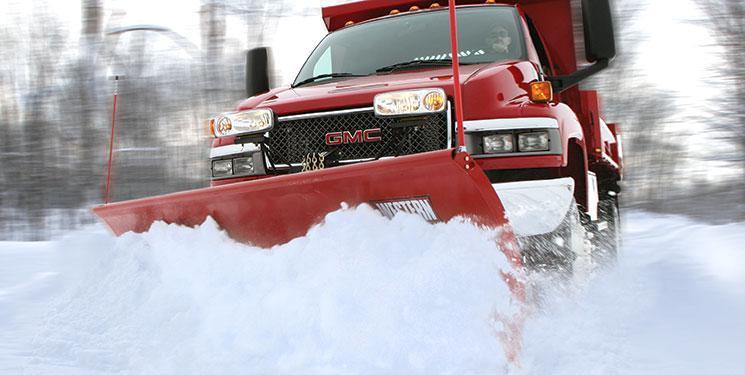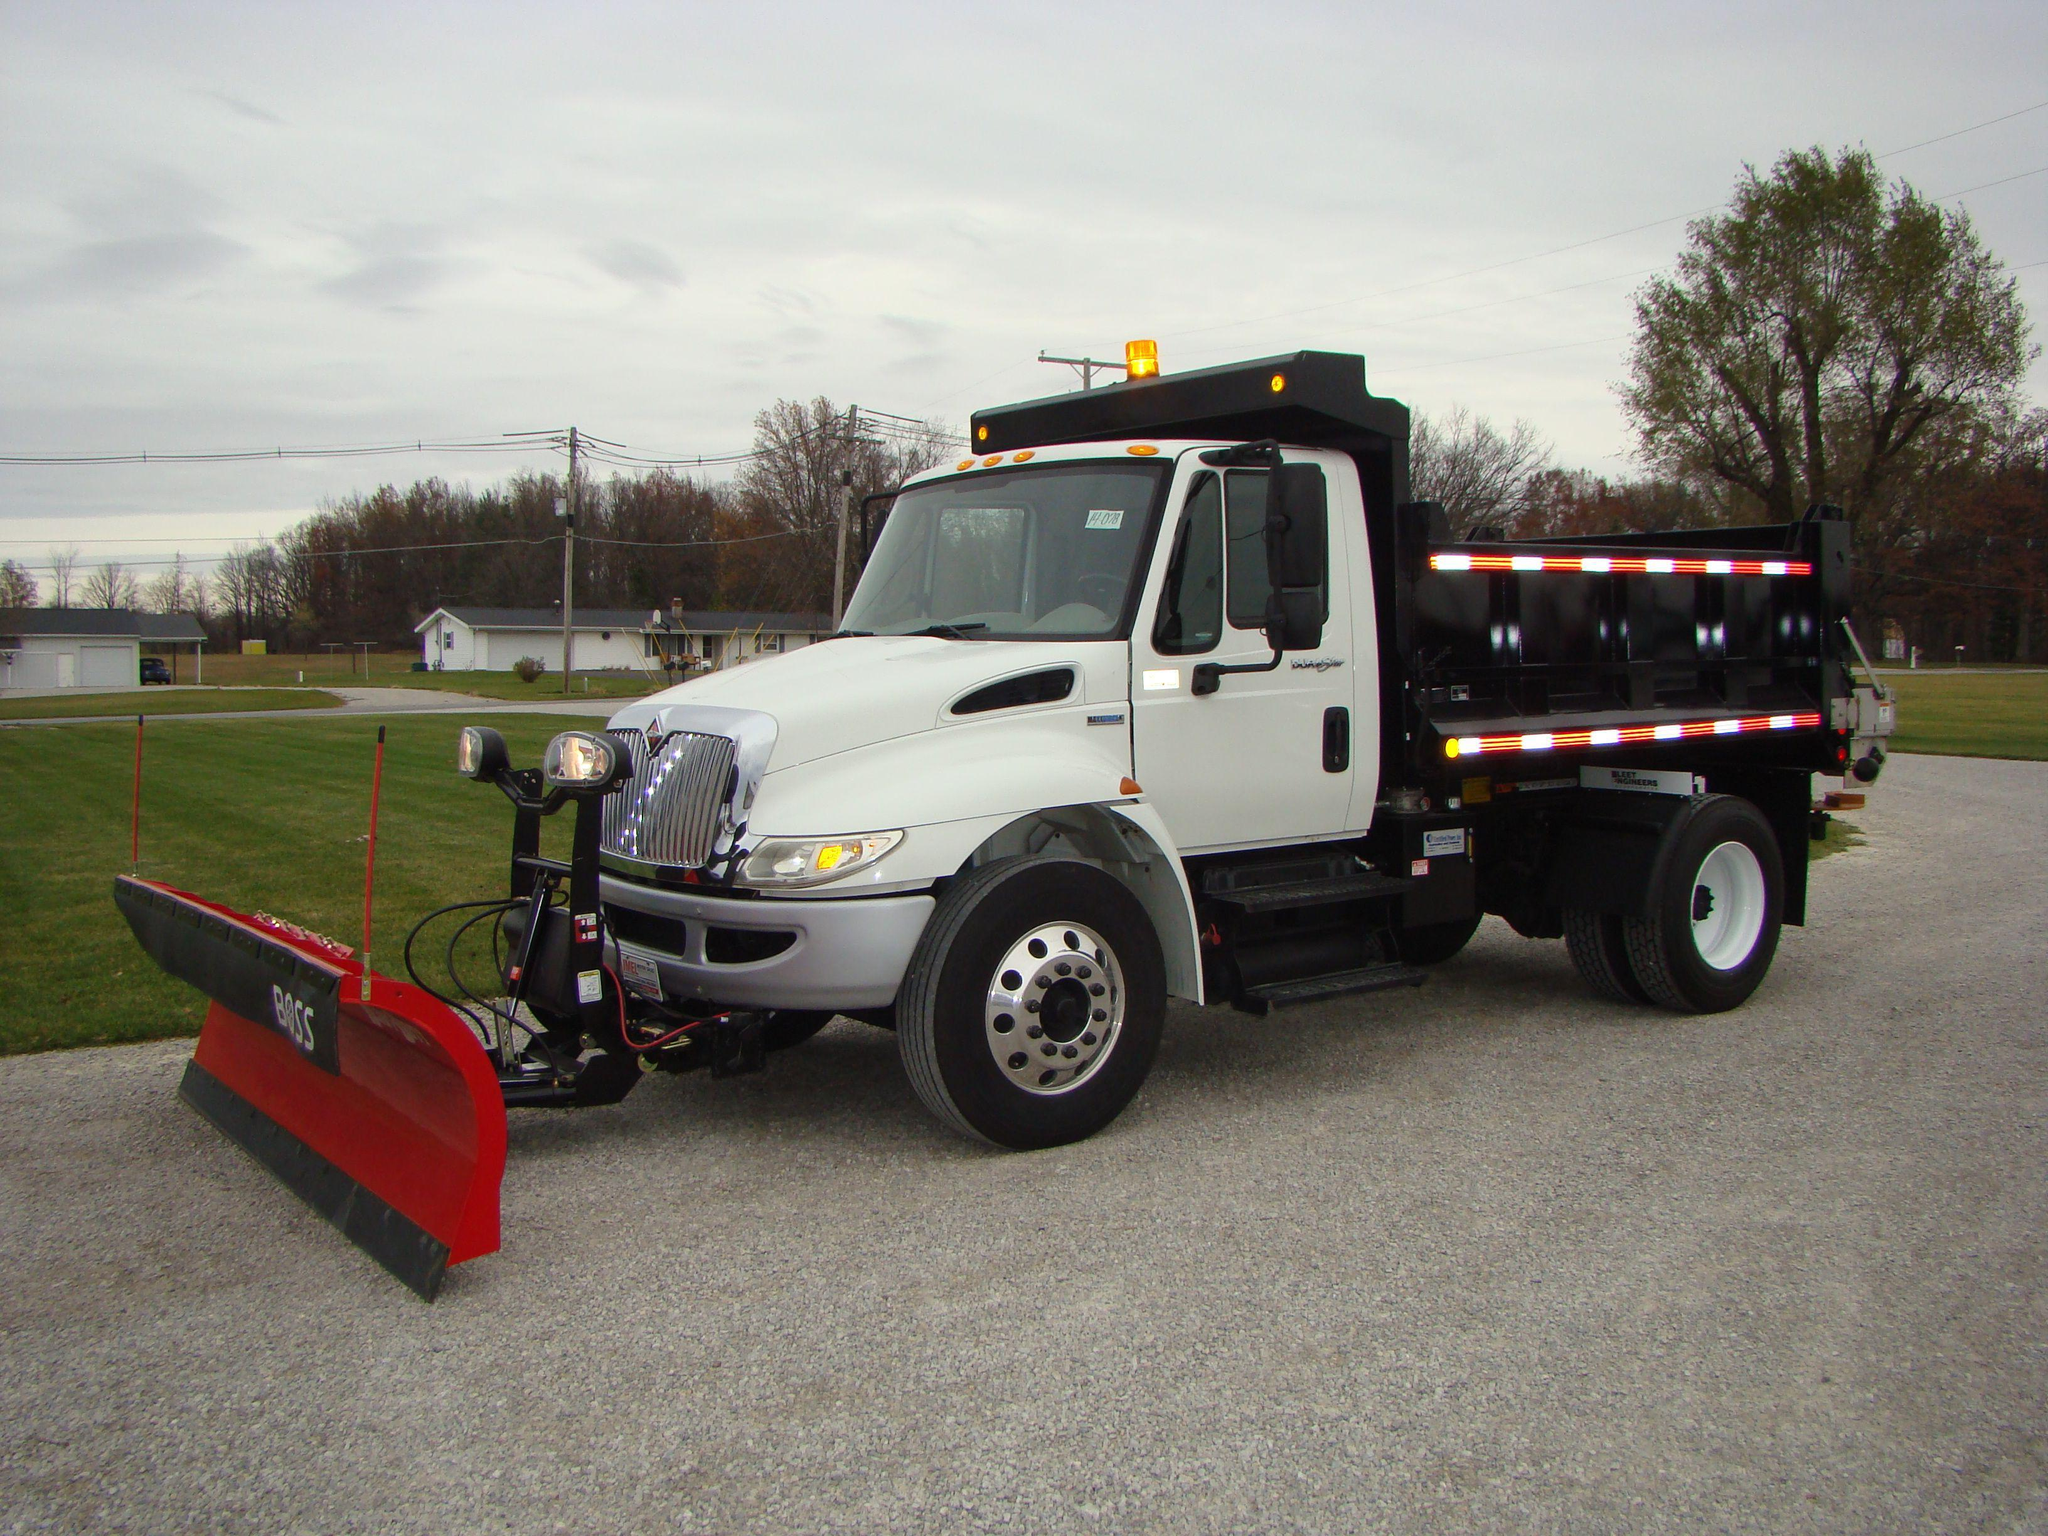The first image is the image on the left, the second image is the image on the right. Evaluate the accuracy of this statement regarding the images: "There are two or more trucks in the right image.". Is it true? Answer yes or no. No. The first image is the image on the left, the second image is the image on the right. For the images shown, is this caption "The left image shows a red truck with a red plow on its front, pushing snow and headed toward the camera." true? Answer yes or no. Yes. 